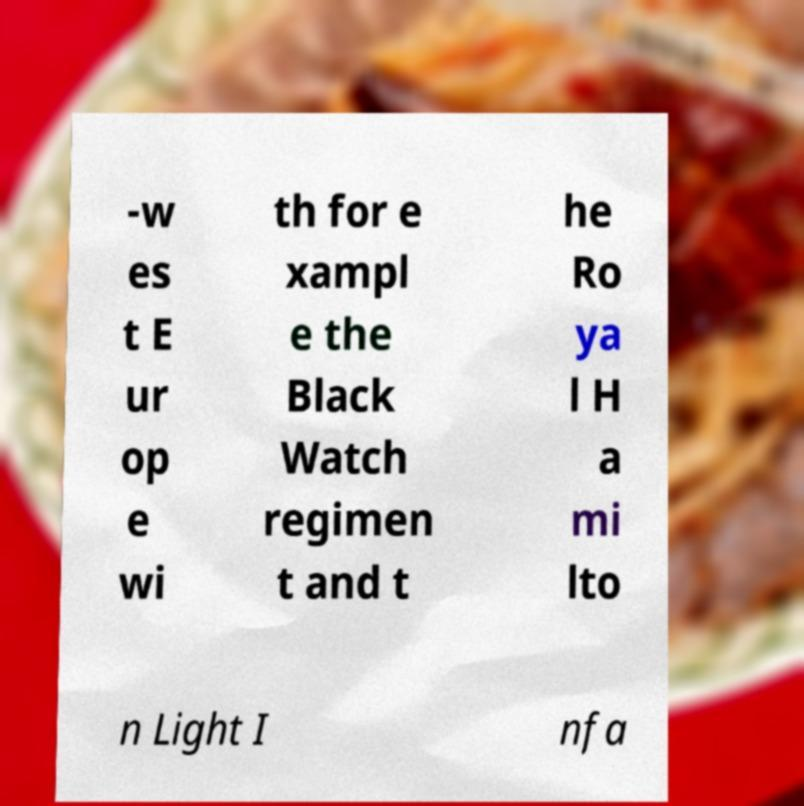Please read and relay the text visible in this image. What does it say? -w es t E ur op e wi th for e xampl e the Black Watch regimen t and t he Ro ya l H a mi lto n Light I nfa 